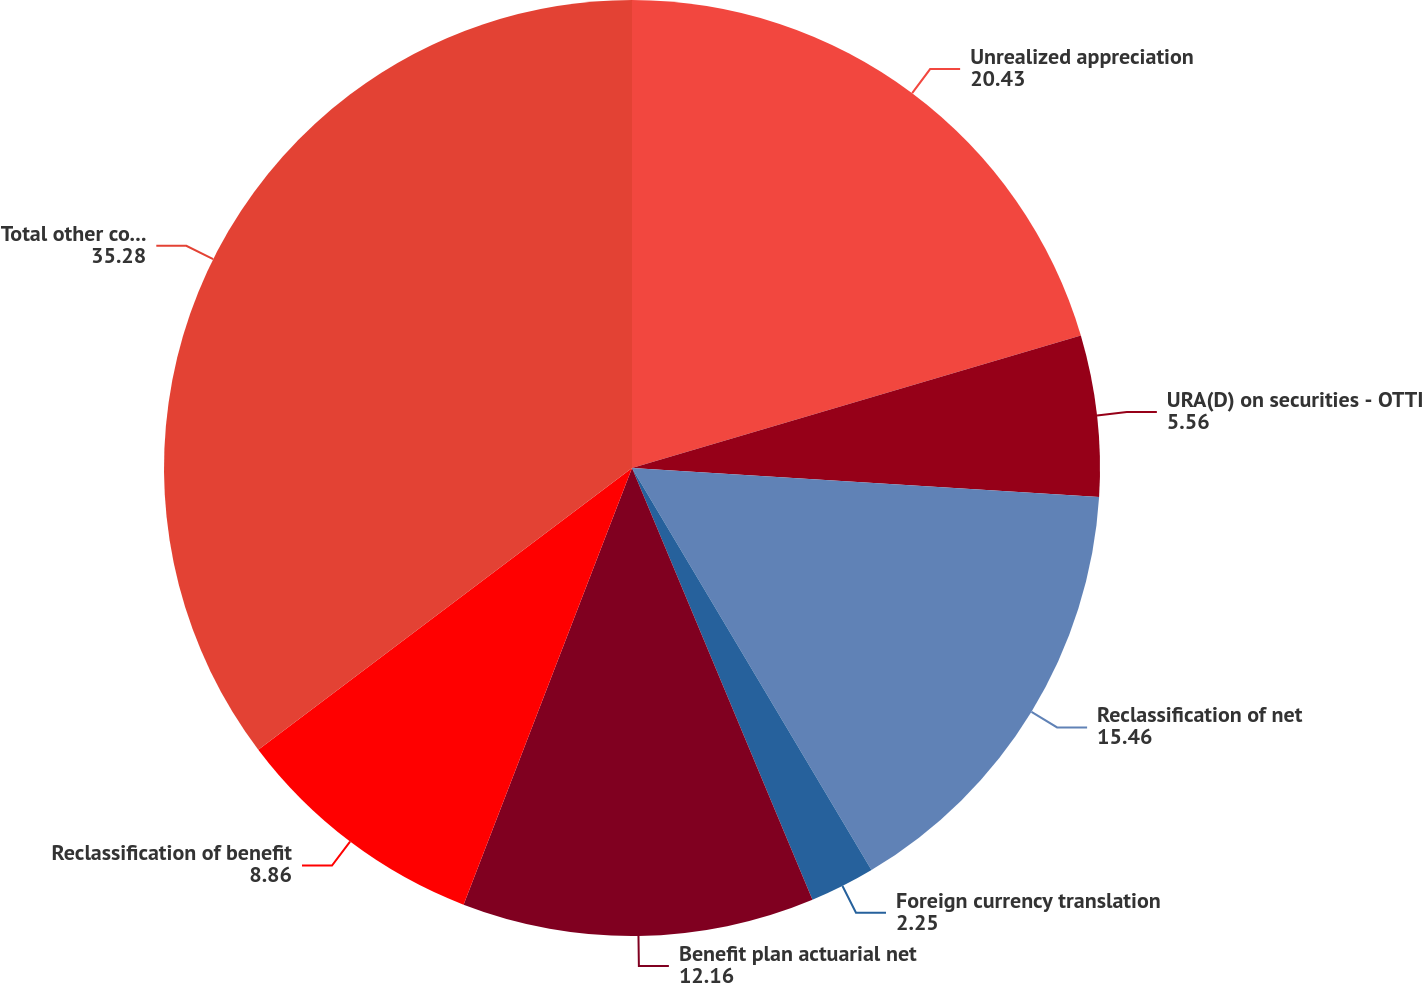Convert chart to OTSL. <chart><loc_0><loc_0><loc_500><loc_500><pie_chart><fcel>Unrealized appreciation<fcel>URA(D) on securities - OTTI<fcel>Reclassification of net<fcel>Foreign currency translation<fcel>Benefit plan actuarial net<fcel>Reclassification of benefit<fcel>Total other comprehensive<nl><fcel>20.43%<fcel>5.56%<fcel>15.46%<fcel>2.25%<fcel>12.16%<fcel>8.86%<fcel>35.28%<nl></chart> 